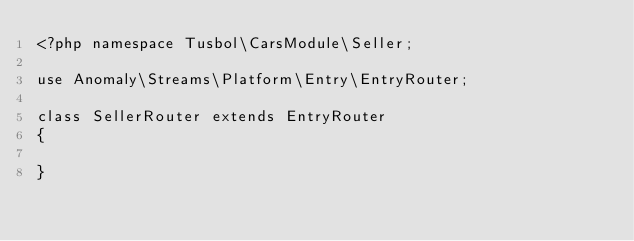<code> <loc_0><loc_0><loc_500><loc_500><_PHP_><?php namespace Tusbol\CarsModule\Seller;

use Anomaly\Streams\Platform\Entry\EntryRouter;

class SellerRouter extends EntryRouter
{

}
</code> 